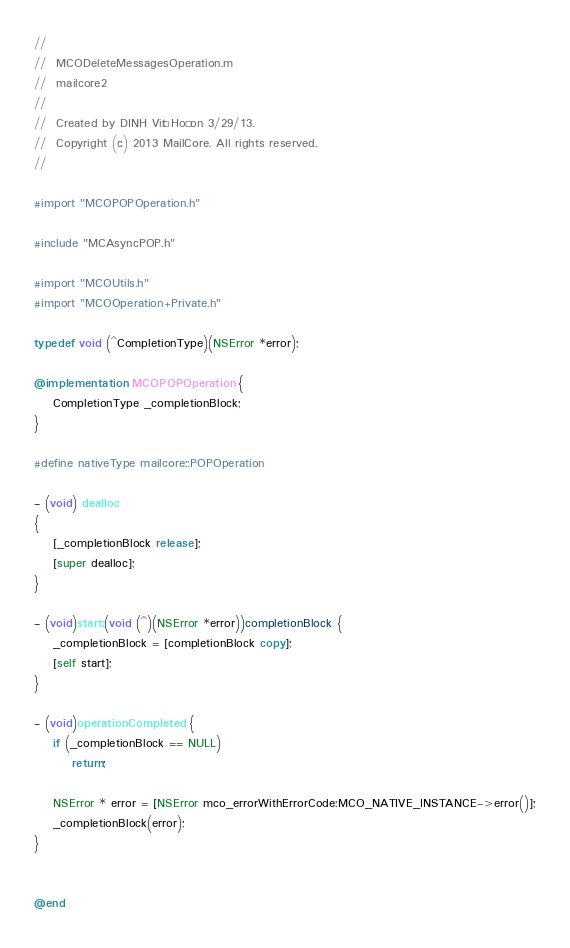Convert code to text. <code><loc_0><loc_0><loc_500><loc_500><_ObjectiveC_>//
//  MCODeleteMessagesOperation.m
//  mailcore2
//
//  Created by DINH Viêt Hoà on 3/29/13.
//  Copyright (c) 2013 MailCore. All rights reserved.
//

#import "MCOPOPOperation.h"

#include "MCAsyncPOP.h"

#import "MCOUtils.h"
#import "MCOOperation+Private.h"

typedef void (^CompletionType)(NSError *error);

@implementation MCOPOPOperation {
    CompletionType _completionBlock;
}

#define nativeType mailcore::POPOperation

- (void) dealloc
{
    [_completionBlock release];
    [super dealloc];
}

- (void)start:(void (^)(NSError *error))completionBlock {
    _completionBlock = [completionBlock copy];
    [self start];
}

- (void)operationCompleted {
    if (_completionBlock == NULL)
        return;
    
    NSError * error = [NSError mco_errorWithErrorCode:MCO_NATIVE_INSTANCE->error()];
    _completionBlock(error);
}


@end
</code> 